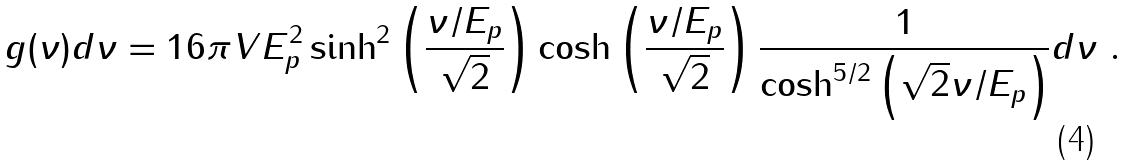<formula> <loc_0><loc_0><loc_500><loc_500>g ( \nu ) d \nu = 1 6 \pi V E _ { p } ^ { 2 } \sinh ^ { 2 } \left ( \frac { \nu / E _ { p } } { \sqrt { 2 } } \right ) \cosh \left ( \frac { \nu / E _ { p } } { \sqrt { 2 } } \right ) \frac { 1 } { \cosh ^ { 5 / 2 } \left ( \sqrt { 2 } \nu / E _ { p } \right ) } d \nu \ .</formula> 